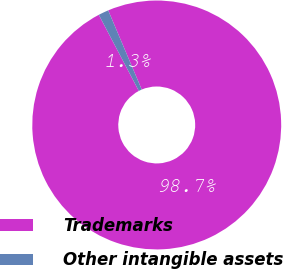<chart> <loc_0><loc_0><loc_500><loc_500><pie_chart><fcel>Trademarks<fcel>Other intangible assets<nl><fcel>98.67%<fcel>1.33%<nl></chart> 